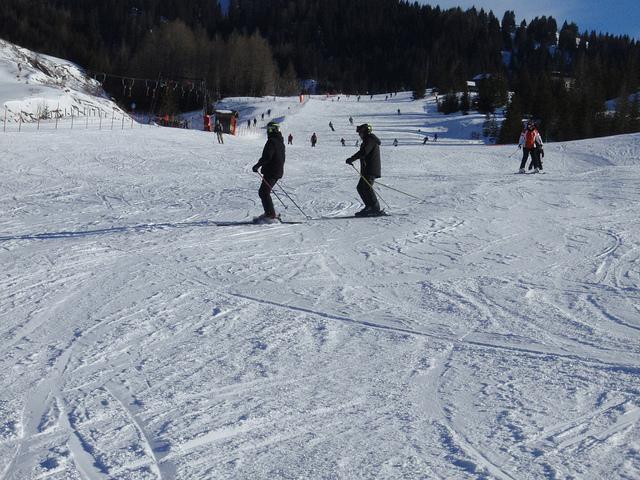Would a zamboni be helpful here?
Answer briefly. No. Is this a crowdy ski area?
Write a very short answer. No. Is there anything orange in the picture?
Answer briefly. Yes. How many people are shown?
Short answer required. 3. Are they going in opposite directions?
Keep it brief. No. 